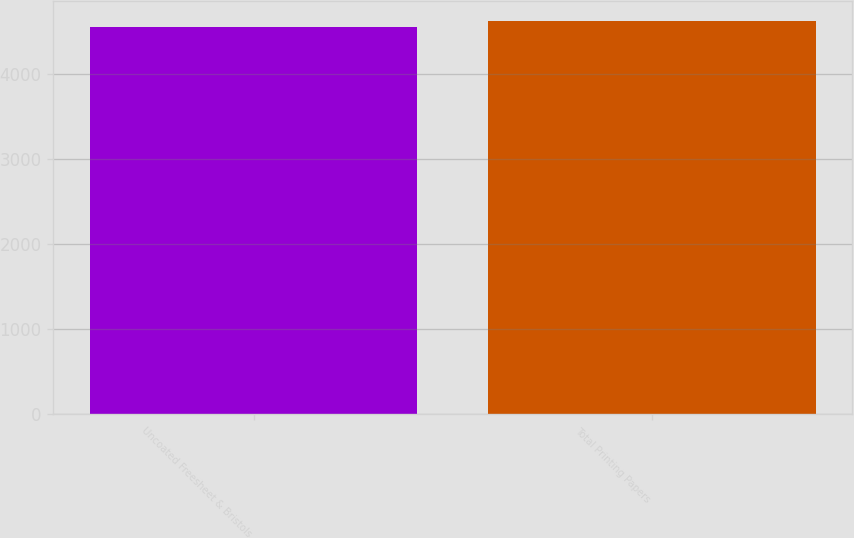Convert chart to OTSL. <chart><loc_0><loc_0><loc_500><loc_500><bar_chart><fcel>Uncoated Freesheet & Bristols<fcel>Total Printing Papers<nl><fcel>4553<fcel>4628<nl></chart> 